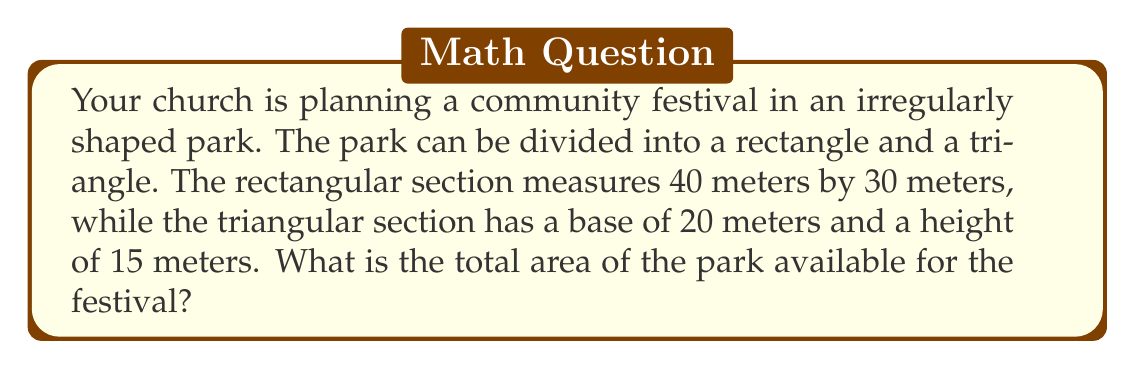What is the answer to this math problem? To find the total area of the irregularly shaped park, we need to:
1. Calculate the area of the rectangular section
2. Calculate the area of the triangular section
3. Add these areas together

Step 1: Area of the rectangle
The formula for the area of a rectangle is:
$$A_r = l \times w$$
where $l$ is length and $w$ is width.

$$A_r = 40 \text{ m} \times 30 \text{ m} = 1200 \text{ m}^2$$

Step 2: Area of the triangle
The formula for the area of a triangle is:
$$A_t = \frac{1}{2} \times b \times h$$
where $b$ is base and $h$ is height.

$$A_t = \frac{1}{2} \times 20 \text{ m} \times 15 \text{ m} = 150 \text{ m}^2$$

Step 3: Total area
Add the areas of the rectangle and triangle:
$$A_{\text{total}} = A_r + A_t = 1200 \text{ m}^2 + 150 \text{ m}^2 = 1350 \text{ m}^2$$

Therefore, the total area of the park available for the festival is 1350 square meters.
Answer: $1350 \text{ m}^2$ 